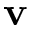Convert formula to latex. <formula><loc_0><loc_0><loc_500><loc_500>v</formula> 